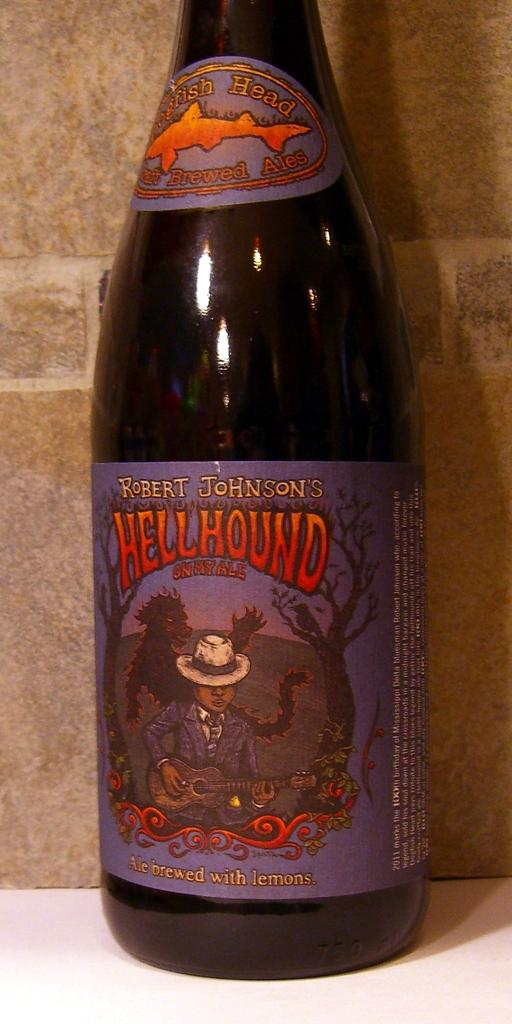<image>
Describe the image concisely. A bottle of Hellhound that was brewed with lemons sits on a counter. 